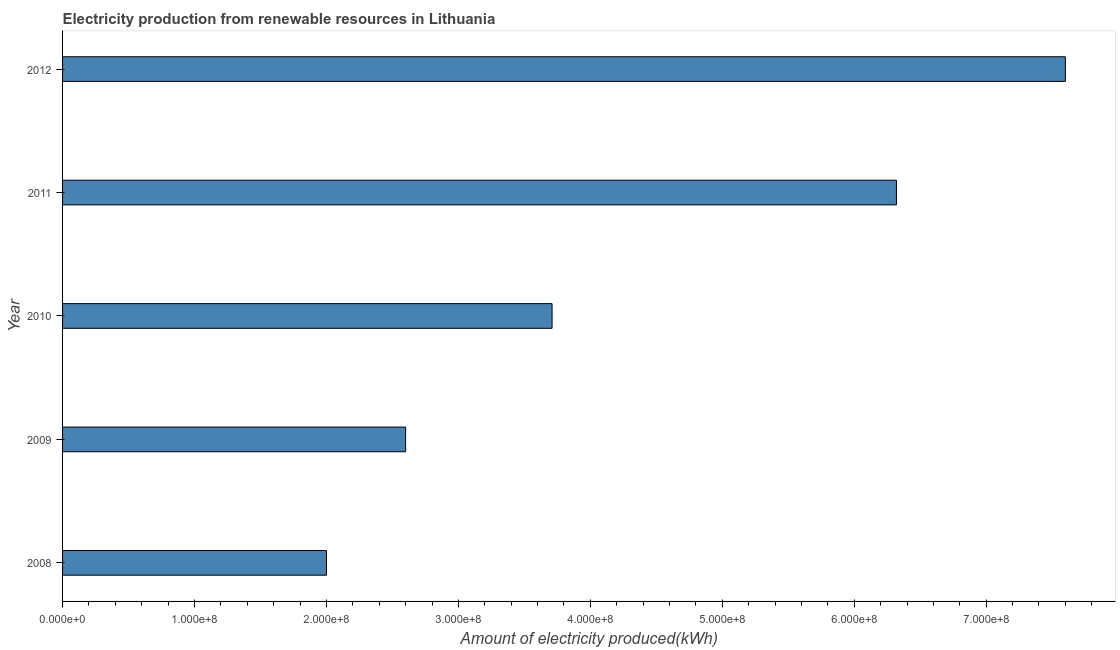Does the graph contain any zero values?
Make the answer very short. No. Does the graph contain grids?
Your response must be concise. No. What is the title of the graph?
Make the answer very short. Electricity production from renewable resources in Lithuania. What is the label or title of the X-axis?
Provide a succinct answer. Amount of electricity produced(kWh). What is the label or title of the Y-axis?
Provide a short and direct response. Year. What is the amount of electricity produced in 2012?
Ensure brevity in your answer.  7.60e+08. Across all years, what is the maximum amount of electricity produced?
Provide a short and direct response. 7.60e+08. In which year was the amount of electricity produced maximum?
Offer a terse response. 2012. What is the sum of the amount of electricity produced?
Your answer should be very brief. 2.22e+09. What is the difference between the amount of electricity produced in 2010 and 2011?
Your response must be concise. -2.61e+08. What is the average amount of electricity produced per year?
Provide a short and direct response. 4.45e+08. What is the median amount of electricity produced?
Give a very brief answer. 3.71e+08. In how many years, is the amount of electricity produced greater than 260000000 kWh?
Give a very brief answer. 3. What is the ratio of the amount of electricity produced in 2008 to that in 2010?
Make the answer very short. 0.54. Is the difference between the amount of electricity produced in 2008 and 2011 greater than the difference between any two years?
Provide a succinct answer. No. What is the difference between the highest and the second highest amount of electricity produced?
Offer a very short reply. 1.28e+08. Is the sum of the amount of electricity produced in 2010 and 2011 greater than the maximum amount of electricity produced across all years?
Provide a succinct answer. Yes. What is the difference between the highest and the lowest amount of electricity produced?
Provide a succinct answer. 5.60e+08. How many years are there in the graph?
Offer a terse response. 5. Are the values on the major ticks of X-axis written in scientific E-notation?
Offer a terse response. Yes. What is the Amount of electricity produced(kWh) in 2009?
Make the answer very short. 2.60e+08. What is the Amount of electricity produced(kWh) in 2010?
Offer a terse response. 3.71e+08. What is the Amount of electricity produced(kWh) of 2011?
Keep it short and to the point. 6.32e+08. What is the Amount of electricity produced(kWh) in 2012?
Ensure brevity in your answer.  7.60e+08. What is the difference between the Amount of electricity produced(kWh) in 2008 and 2009?
Your answer should be compact. -6.00e+07. What is the difference between the Amount of electricity produced(kWh) in 2008 and 2010?
Provide a short and direct response. -1.71e+08. What is the difference between the Amount of electricity produced(kWh) in 2008 and 2011?
Ensure brevity in your answer.  -4.32e+08. What is the difference between the Amount of electricity produced(kWh) in 2008 and 2012?
Provide a succinct answer. -5.60e+08. What is the difference between the Amount of electricity produced(kWh) in 2009 and 2010?
Provide a succinct answer. -1.11e+08. What is the difference between the Amount of electricity produced(kWh) in 2009 and 2011?
Your answer should be very brief. -3.72e+08. What is the difference between the Amount of electricity produced(kWh) in 2009 and 2012?
Your response must be concise. -5.00e+08. What is the difference between the Amount of electricity produced(kWh) in 2010 and 2011?
Make the answer very short. -2.61e+08. What is the difference between the Amount of electricity produced(kWh) in 2010 and 2012?
Provide a short and direct response. -3.89e+08. What is the difference between the Amount of electricity produced(kWh) in 2011 and 2012?
Provide a short and direct response. -1.28e+08. What is the ratio of the Amount of electricity produced(kWh) in 2008 to that in 2009?
Keep it short and to the point. 0.77. What is the ratio of the Amount of electricity produced(kWh) in 2008 to that in 2010?
Provide a succinct answer. 0.54. What is the ratio of the Amount of electricity produced(kWh) in 2008 to that in 2011?
Provide a short and direct response. 0.32. What is the ratio of the Amount of electricity produced(kWh) in 2008 to that in 2012?
Give a very brief answer. 0.26. What is the ratio of the Amount of electricity produced(kWh) in 2009 to that in 2010?
Your answer should be compact. 0.7. What is the ratio of the Amount of electricity produced(kWh) in 2009 to that in 2011?
Give a very brief answer. 0.41. What is the ratio of the Amount of electricity produced(kWh) in 2009 to that in 2012?
Provide a succinct answer. 0.34. What is the ratio of the Amount of electricity produced(kWh) in 2010 to that in 2011?
Provide a short and direct response. 0.59. What is the ratio of the Amount of electricity produced(kWh) in 2010 to that in 2012?
Give a very brief answer. 0.49. What is the ratio of the Amount of electricity produced(kWh) in 2011 to that in 2012?
Your answer should be compact. 0.83. 